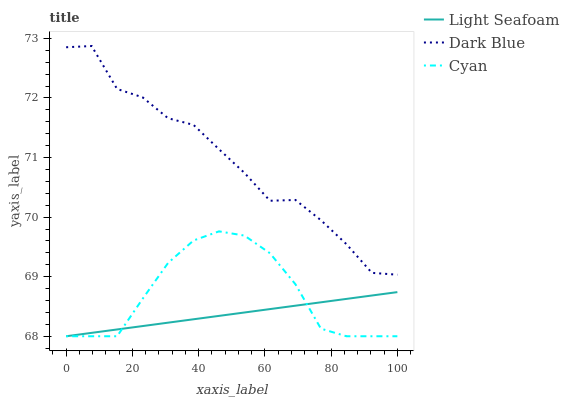Does Light Seafoam have the minimum area under the curve?
Answer yes or no. Yes. Does Dark Blue have the maximum area under the curve?
Answer yes or no. Yes. Does Cyan have the minimum area under the curve?
Answer yes or no. No. Does Cyan have the maximum area under the curve?
Answer yes or no. No. Is Light Seafoam the smoothest?
Answer yes or no. Yes. Is Dark Blue the roughest?
Answer yes or no. Yes. Is Cyan the smoothest?
Answer yes or no. No. Is Cyan the roughest?
Answer yes or no. No. Does Dark Blue have the highest value?
Answer yes or no. Yes. Does Cyan have the highest value?
Answer yes or no. No. Is Cyan less than Dark Blue?
Answer yes or no. Yes. Is Dark Blue greater than Cyan?
Answer yes or no. Yes. Does Cyan intersect Light Seafoam?
Answer yes or no. Yes. Is Cyan less than Light Seafoam?
Answer yes or no. No. Is Cyan greater than Light Seafoam?
Answer yes or no. No. Does Cyan intersect Dark Blue?
Answer yes or no. No. 